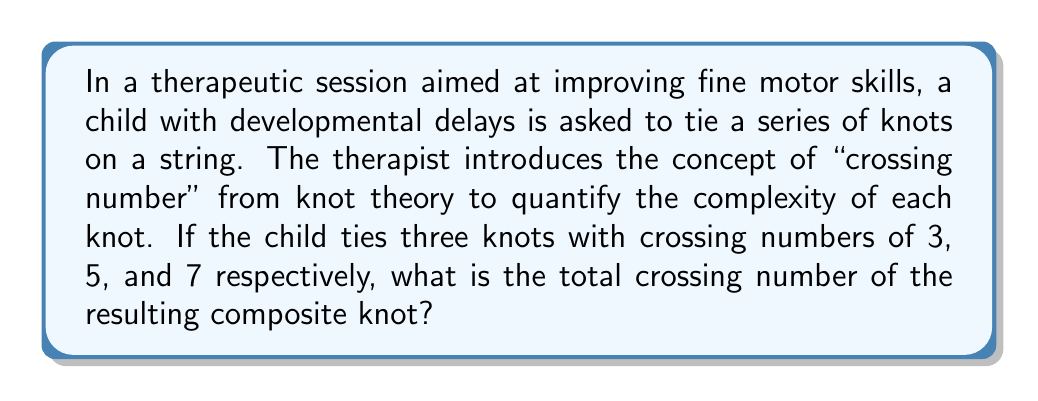Give your solution to this math problem. To solve this problem, we need to understand and apply the concept of crossing numbers in knot theory:

1. In knot theory, the crossing number of a knot is the minimum number of crossings that occur in any projection of the knot onto a plane.

2. For a composite knot (formed by connecting two or more knots), the crossing number is additive. This means that the crossing number of a composite knot is the sum of the crossing numbers of its component knots.

3. In this case, we have three knots with crossing numbers:
   - Knot 1: 3
   - Knot 2: 5
   - Knot 3: 7

4. To find the total crossing number of the composite knot, we simply add these individual crossing numbers:

   $$\text{Total Crossing Number} = 3 + 5 + 7 = 15$$

This additive property of crossing numbers in composite knots is useful in therapy settings as it allows for a quantitative measure of the complexity of knots tied by children, helping to track progress in fine motor skill development.
Answer: 15 